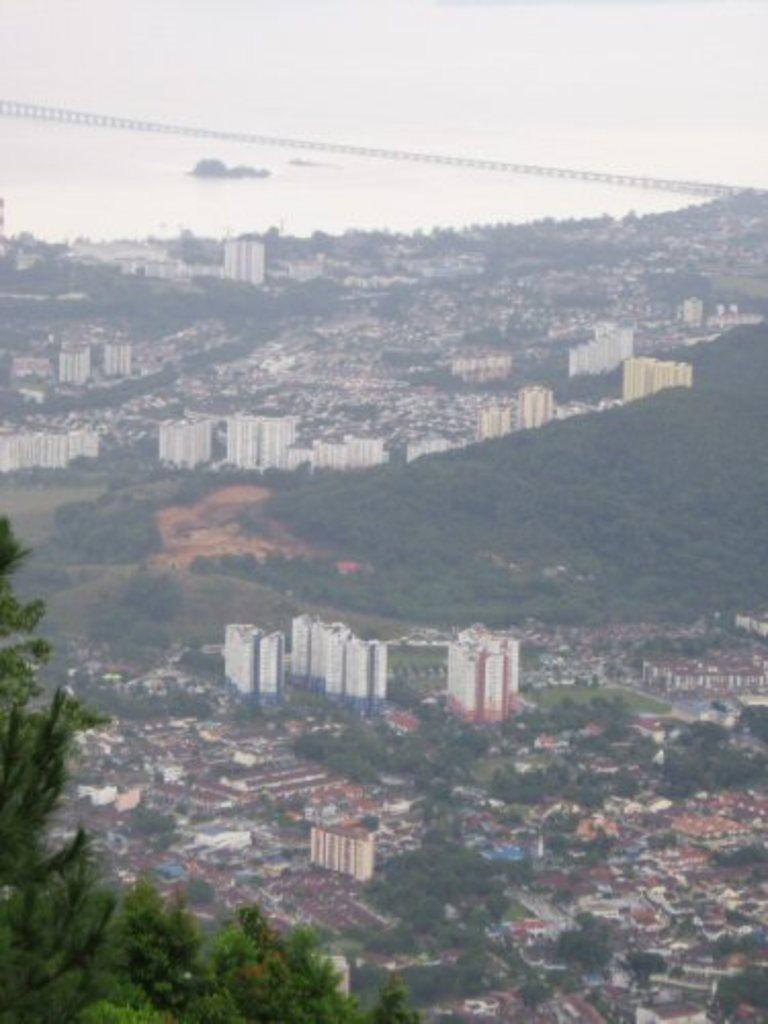Please provide a concise description of this image. This is an aerial view of an image where we can see the trees on the left side of the image and we can see many buildings, trees, water and the bridge in the background. 